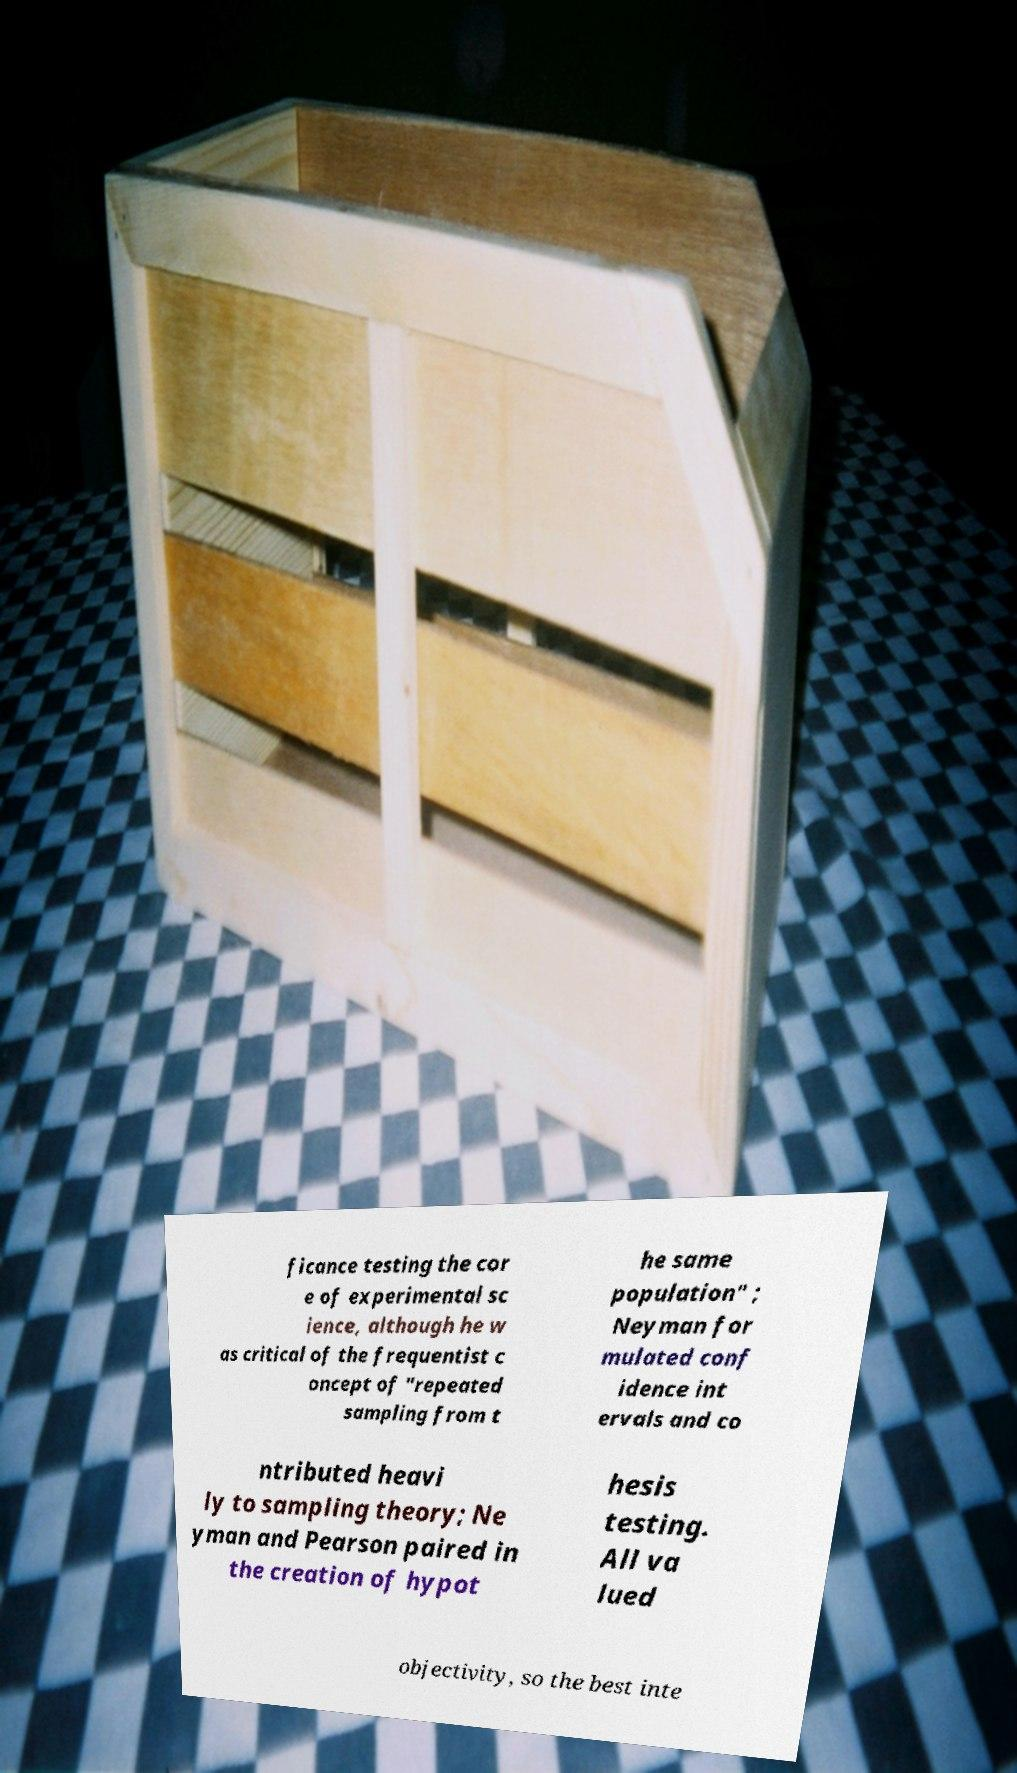Could you extract and type out the text from this image? ficance testing the cor e of experimental sc ience, although he w as critical of the frequentist c oncept of "repeated sampling from t he same population" ; Neyman for mulated conf idence int ervals and co ntributed heavi ly to sampling theory; Ne yman and Pearson paired in the creation of hypot hesis testing. All va lued objectivity, so the best inte 